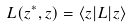<formula> <loc_0><loc_0><loc_500><loc_500>L ( { z } ^ { * } , { z } ) = \langle { z } | L | { z } \rangle</formula> 